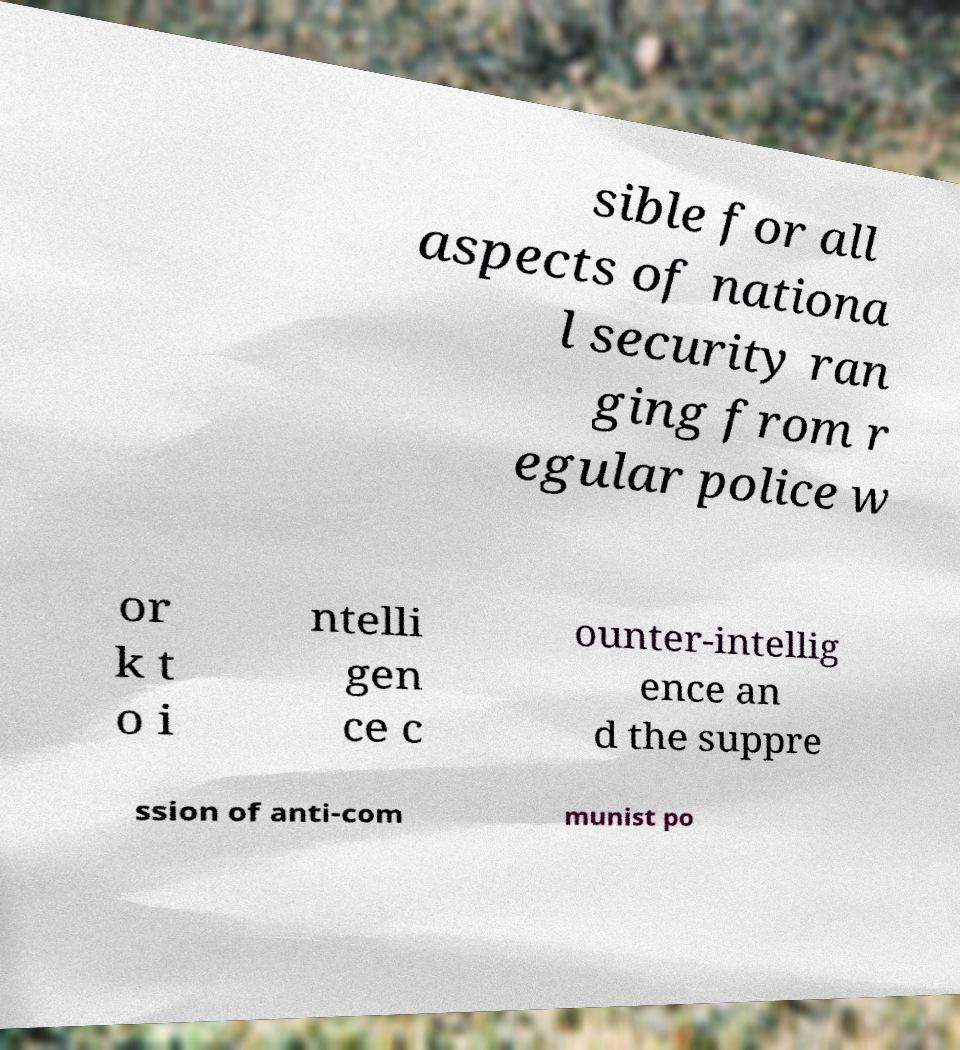Could you extract and type out the text from this image? sible for all aspects of nationa l security ran ging from r egular police w or k t o i ntelli gen ce c ounter-intellig ence an d the suppre ssion of anti-com munist po 